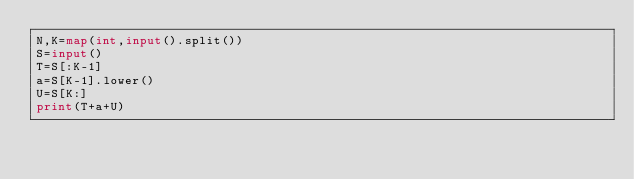<code> <loc_0><loc_0><loc_500><loc_500><_Python_>N,K=map(int,input().split())
S=input()
T=S[:K-1]
a=S[K-1].lower()
U=S[K:]
print(T+a+U)</code> 